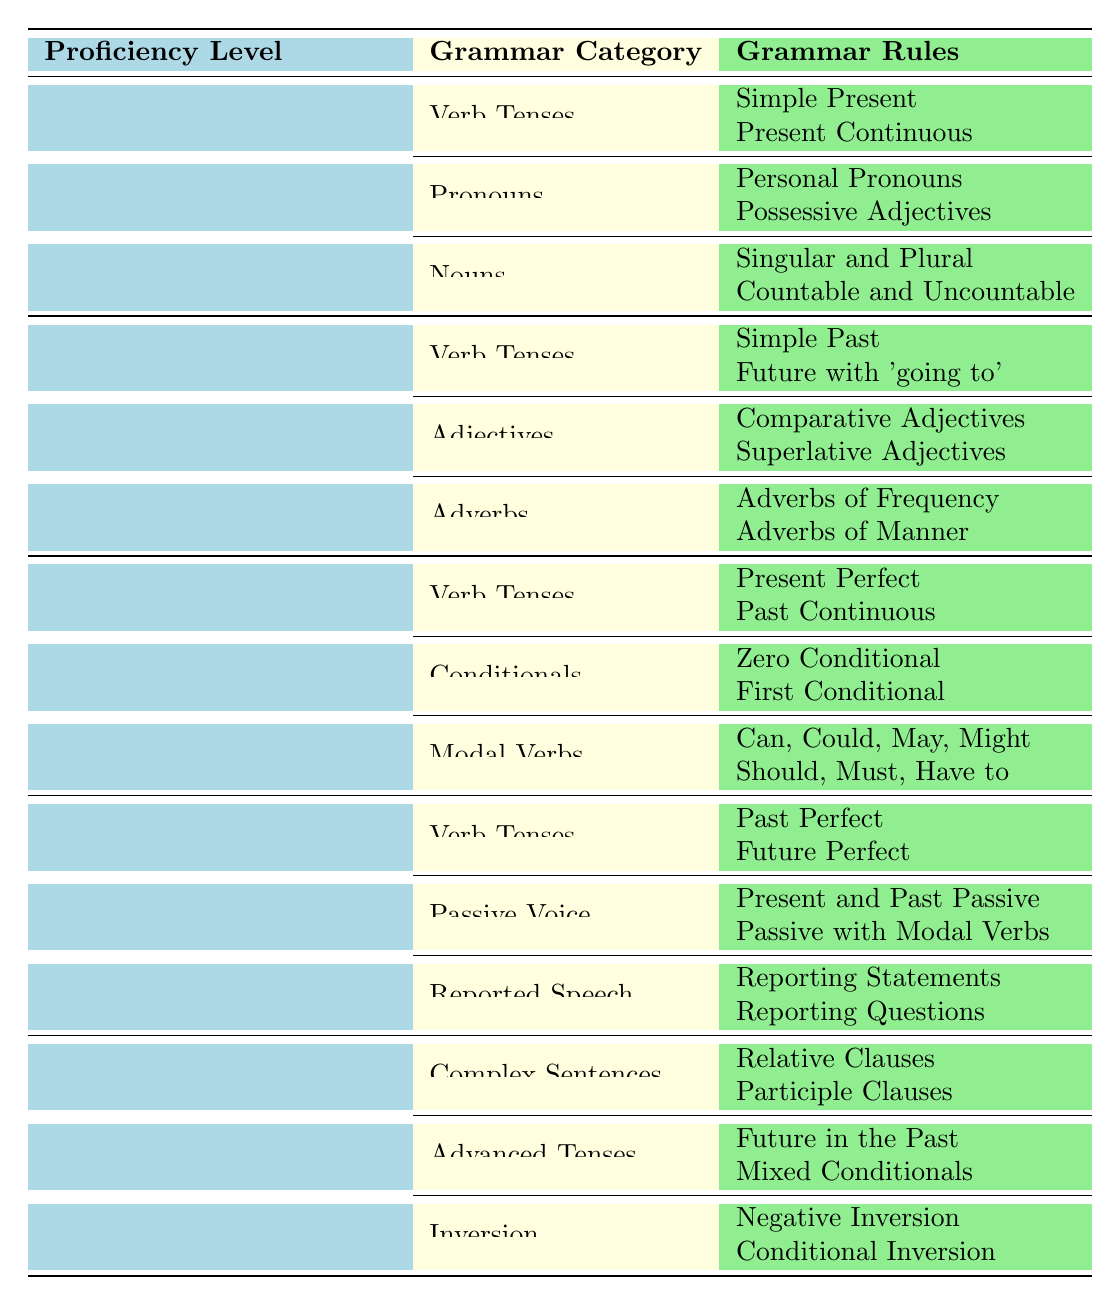What grammar rules are taught at the Beginner (A1) level? The table lists the grammar rules under the Beginner (A1) level, which includes categories of Verb Tenses, Pronouns, and Nouns with their respective rules: Simple Present, Present Continuous, Personal Pronouns, Possessive Adjectives, Singular and Plural, and Countable and Uncountable.
Answer: Simple Present, Present Continuous, Personal Pronouns, Possessive Adjectives, Singular and Plural, Countable and Uncountable How many grammar categories are there at the Intermediate (B1) level? The table shows that there are three grammar categories under the Intermediate (B1) level: Verb Tenses, Conditionals, and Modal Verbs.
Answer: 3 Is "Future Perfect" a grammar rule taught in the Upper Intermediate (B2) level? The table indicates that "Future Perfect" is listed under the Verb Tenses category for the Upper Intermediate (B2) level. Thus, the statement is true.
Answer: Yes What is the difference between the verb tenses taught at the Beginner (A1) and Intermediate (B1) levels? For Beginner (A1), the verb tenses taught are Simple Present and Present Continuous. In contrast, the Intermediate (B1) level adds Present Perfect and Past Continuous. Therefore, the Intermediate level covers more advanced tenses than the Beginner level.
Answer: Intermediate level covers more advanced tenses Which grammar category has the most rules listed at the Advanced (C1) level? The table indicates that the Advanced (C1) level has three categories: Complex Sentences, Advanced Tenses, and Inversion, each having two rules. Therefore, no single category has more rules than the others; they are equal in number.
Answer: No single category has more rules Can you list all the modal verbs introduced at the Intermediate (B1) level? The table under the Modal Verbs category for Intermediate (B1) level mentions the rules: "Can, Could, May, Might" and "Should, Must, Have to." All of these are modal verbs.
Answer: Can, Could, May, Might, Should, Must, Have to How many total grammar rules are specified across all categories in the Elementary (A2) level? In the Elementary (A2) level, the table indicates three categories: Verb Tenses (2 rules), Adjectives (2 rules), and Adverbs (2 rules). Adding these gives a total of 6 rules for the Elementary level.
Answer: 6 Which proficiency level includes "Reporting Questions" in its grammar rules? Referring to the table, "Reporting Questions" is listed under the Reported Speech category within the Upper Intermediate (B2) level.
Answer: Upper Intermediate (B2) level What is the relationship between "Negative Inversion" and "Conditional Inversion" at the Advanced (C1) level? The table shows that both "Negative Inversion" and "Conditional Inversion" fall under the Inversion category at the Advanced (C1) level, indicating they relate to the same grammar concept of inversion in sentences.
Answer: They are related as part of the same Inversion category 